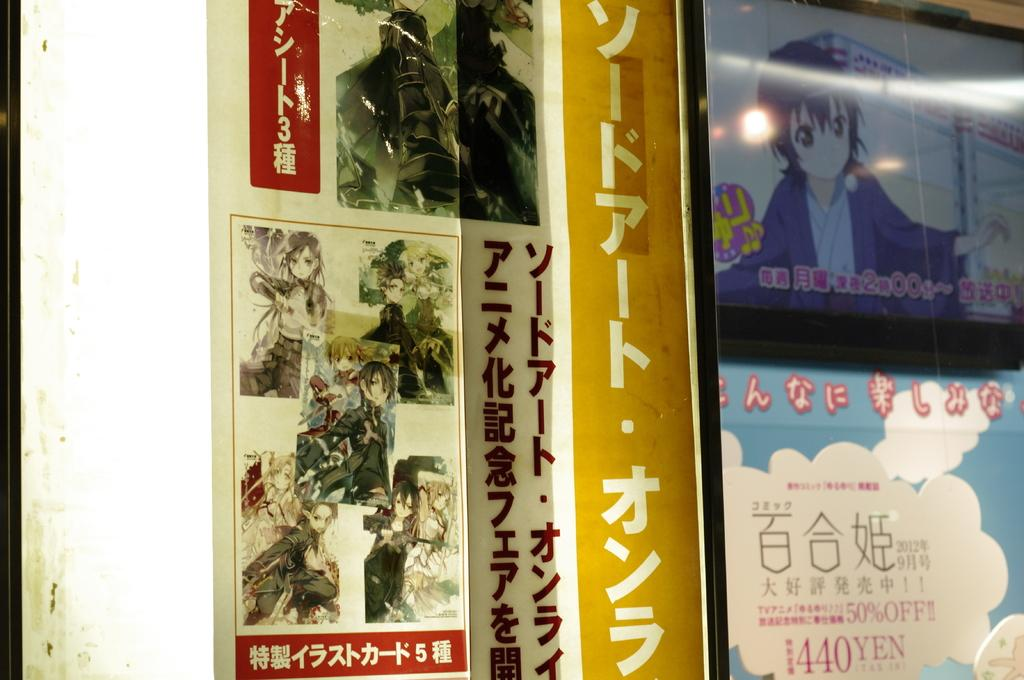<image>
Share a concise interpretation of the image provided. A price is displayed as being 1440 yen on an item 